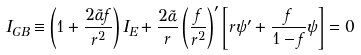<formula> <loc_0><loc_0><loc_500><loc_500>I _ { G B } \equiv \left ( 1 + \frac { 2 \tilde { \alpha } f } { r ^ { 2 } } \right ) { I _ { E } } + \frac { 2 \tilde { \alpha } } { r } \left ( \frac { f } { r ^ { 2 } } \right ) ^ { \prime } \left [ r \psi ^ { \prime } + \frac { f } { 1 - f } \psi \right ] = 0</formula> 